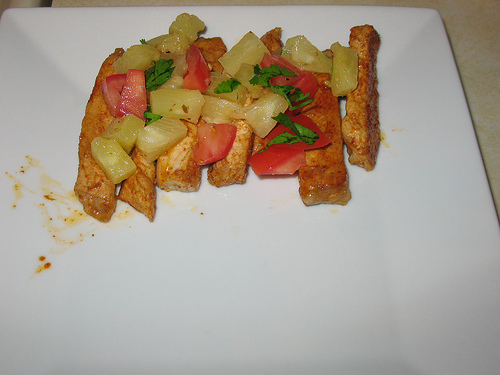<image>
Is the plate under the food? Yes. The plate is positioned underneath the food, with the food above it in the vertical space. 